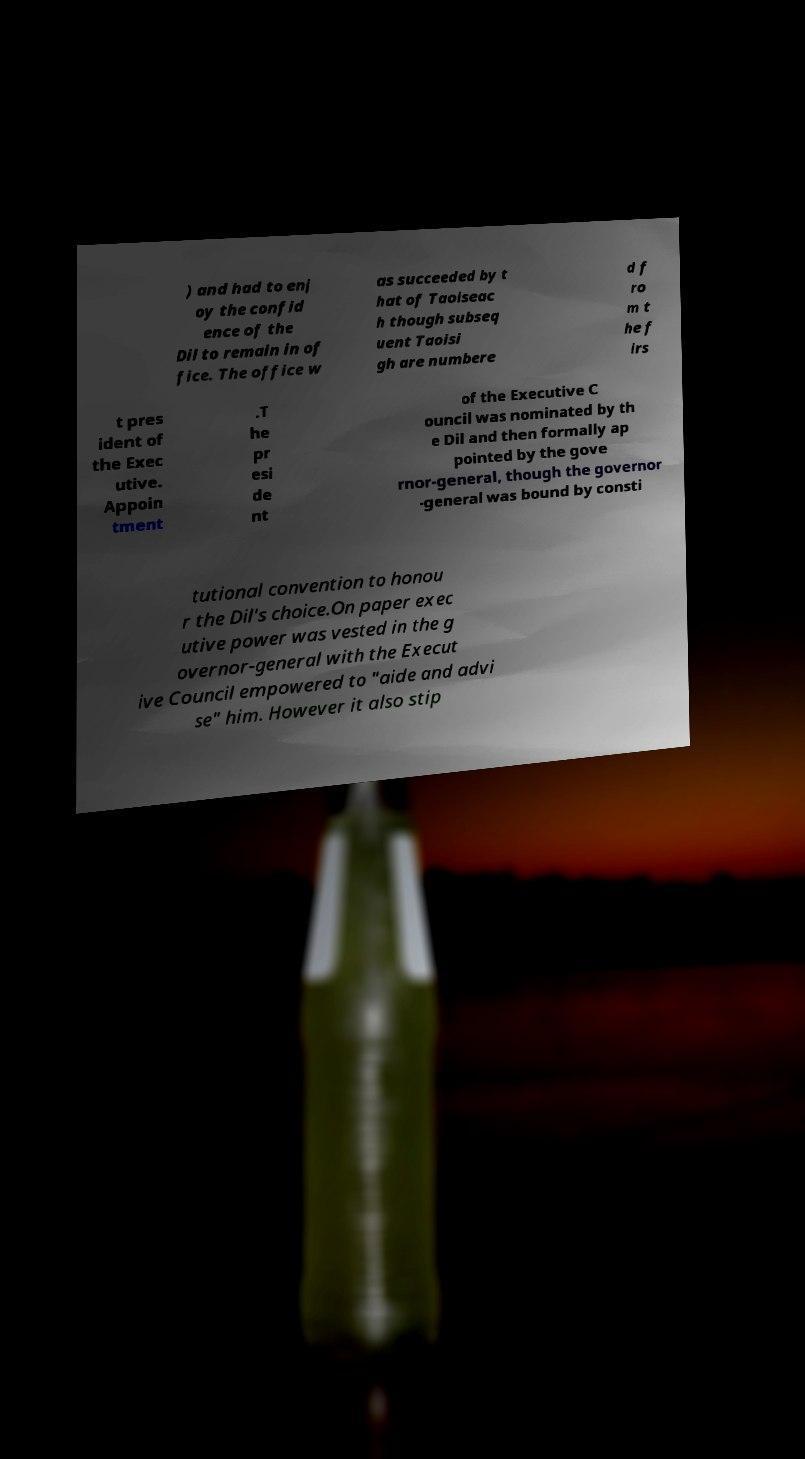Can you accurately transcribe the text from the provided image for me? ) and had to enj oy the confid ence of the Dil to remain in of fice. The office w as succeeded by t hat of Taoiseac h though subseq uent Taoisi gh are numbere d f ro m t he f irs t pres ident of the Exec utive. Appoin tment .T he pr esi de nt of the Executive C ouncil was nominated by th e Dil and then formally ap pointed by the gove rnor-general, though the governor -general was bound by consti tutional convention to honou r the Dil's choice.On paper exec utive power was vested in the g overnor-general with the Execut ive Council empowered to "aide and advi se" him. However it also stip 